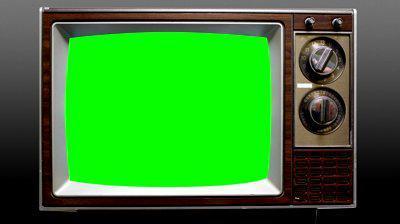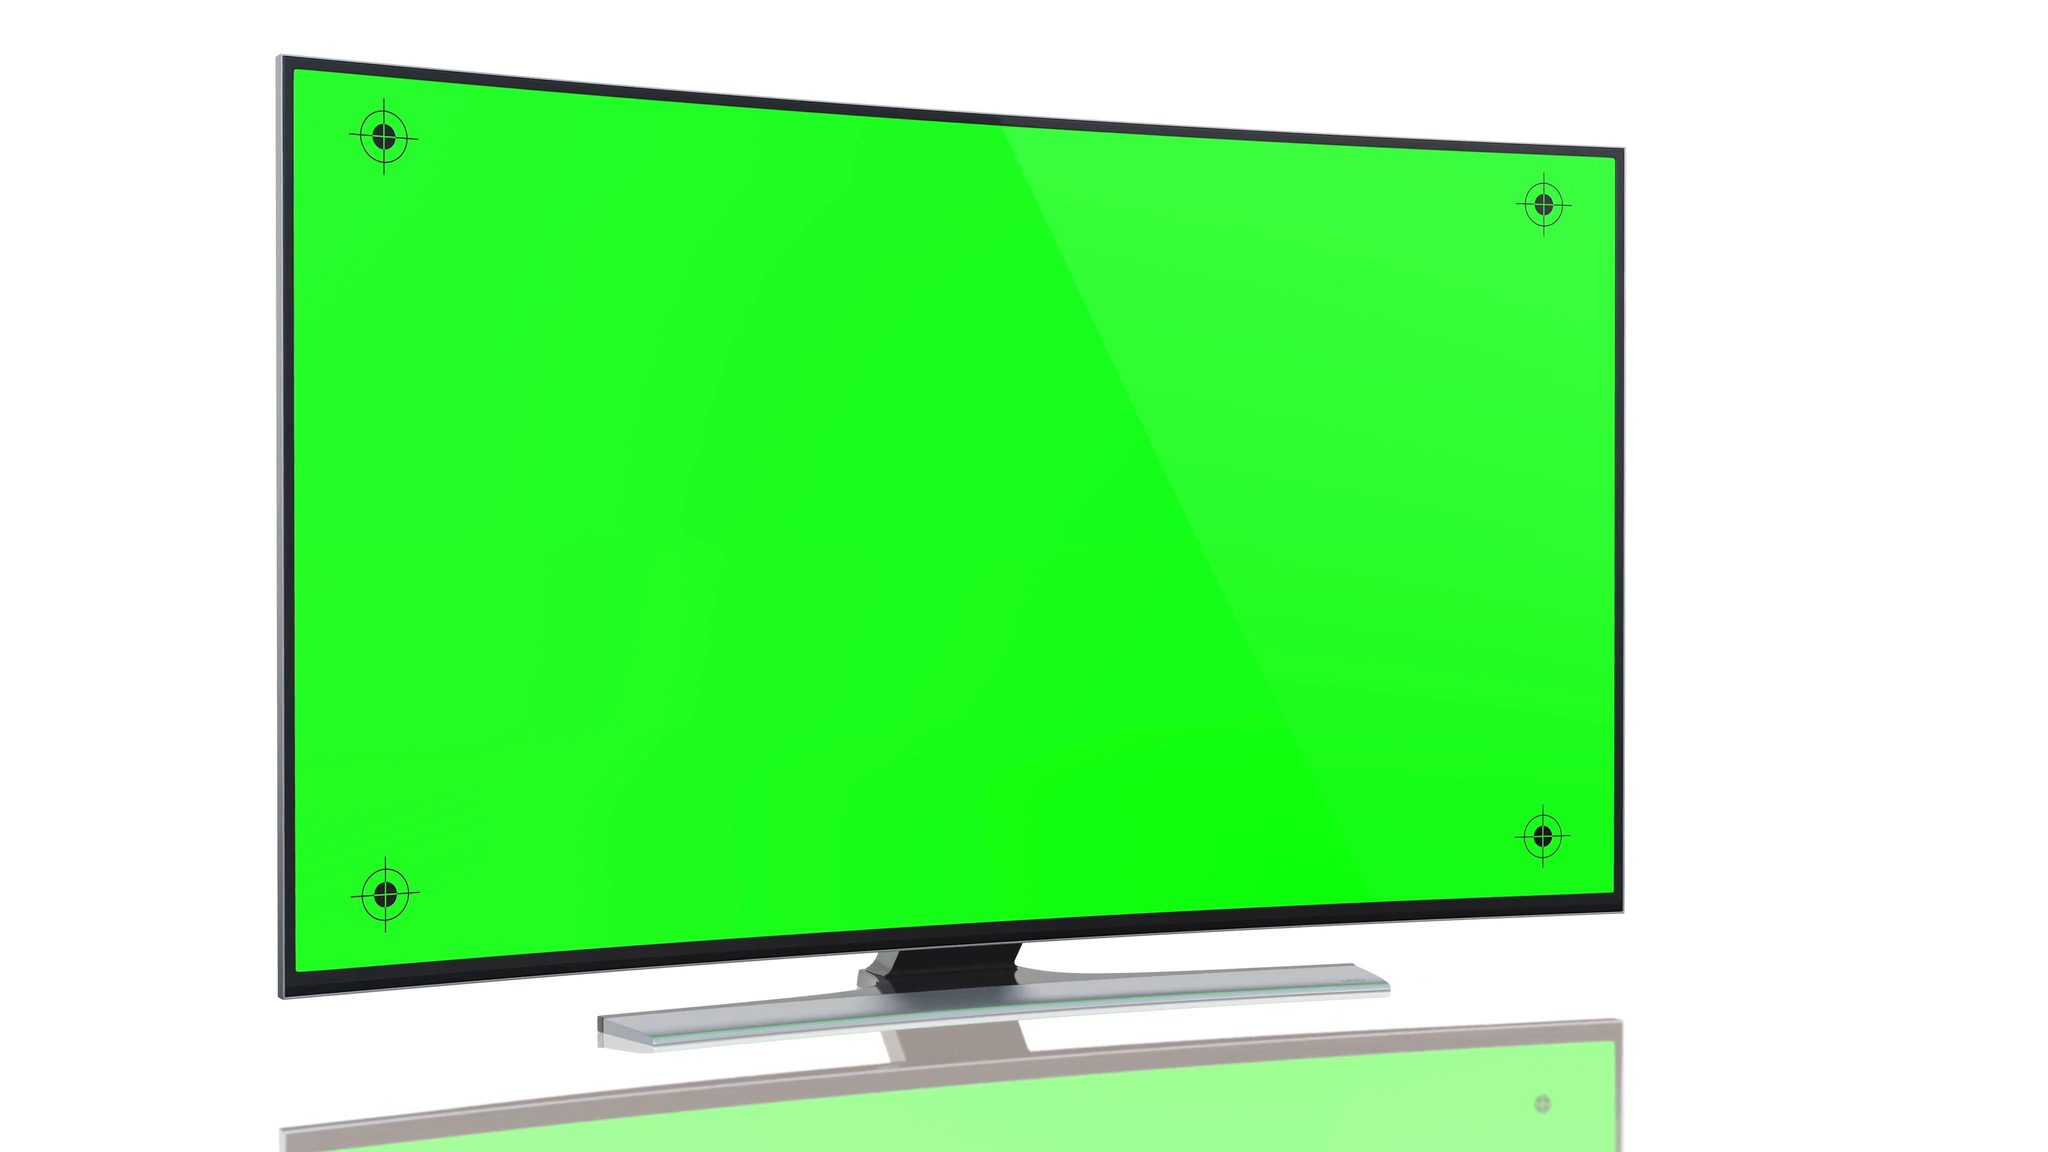The first image is the image on the left, the second image is the image on the right. For the images displayed, is the sentence "One glowing green TV screen is modern, flat and wide, and the other glowing green screen is in an old-fashioned box-like TV set." factually correct? Answer yes or no. Yes. The first image is the image on the left, the second image is the image on the right. Assess this claim about the two images: "A single television with a bright green screen has a blue background.". Correct or not? Answer yes or no. No. 